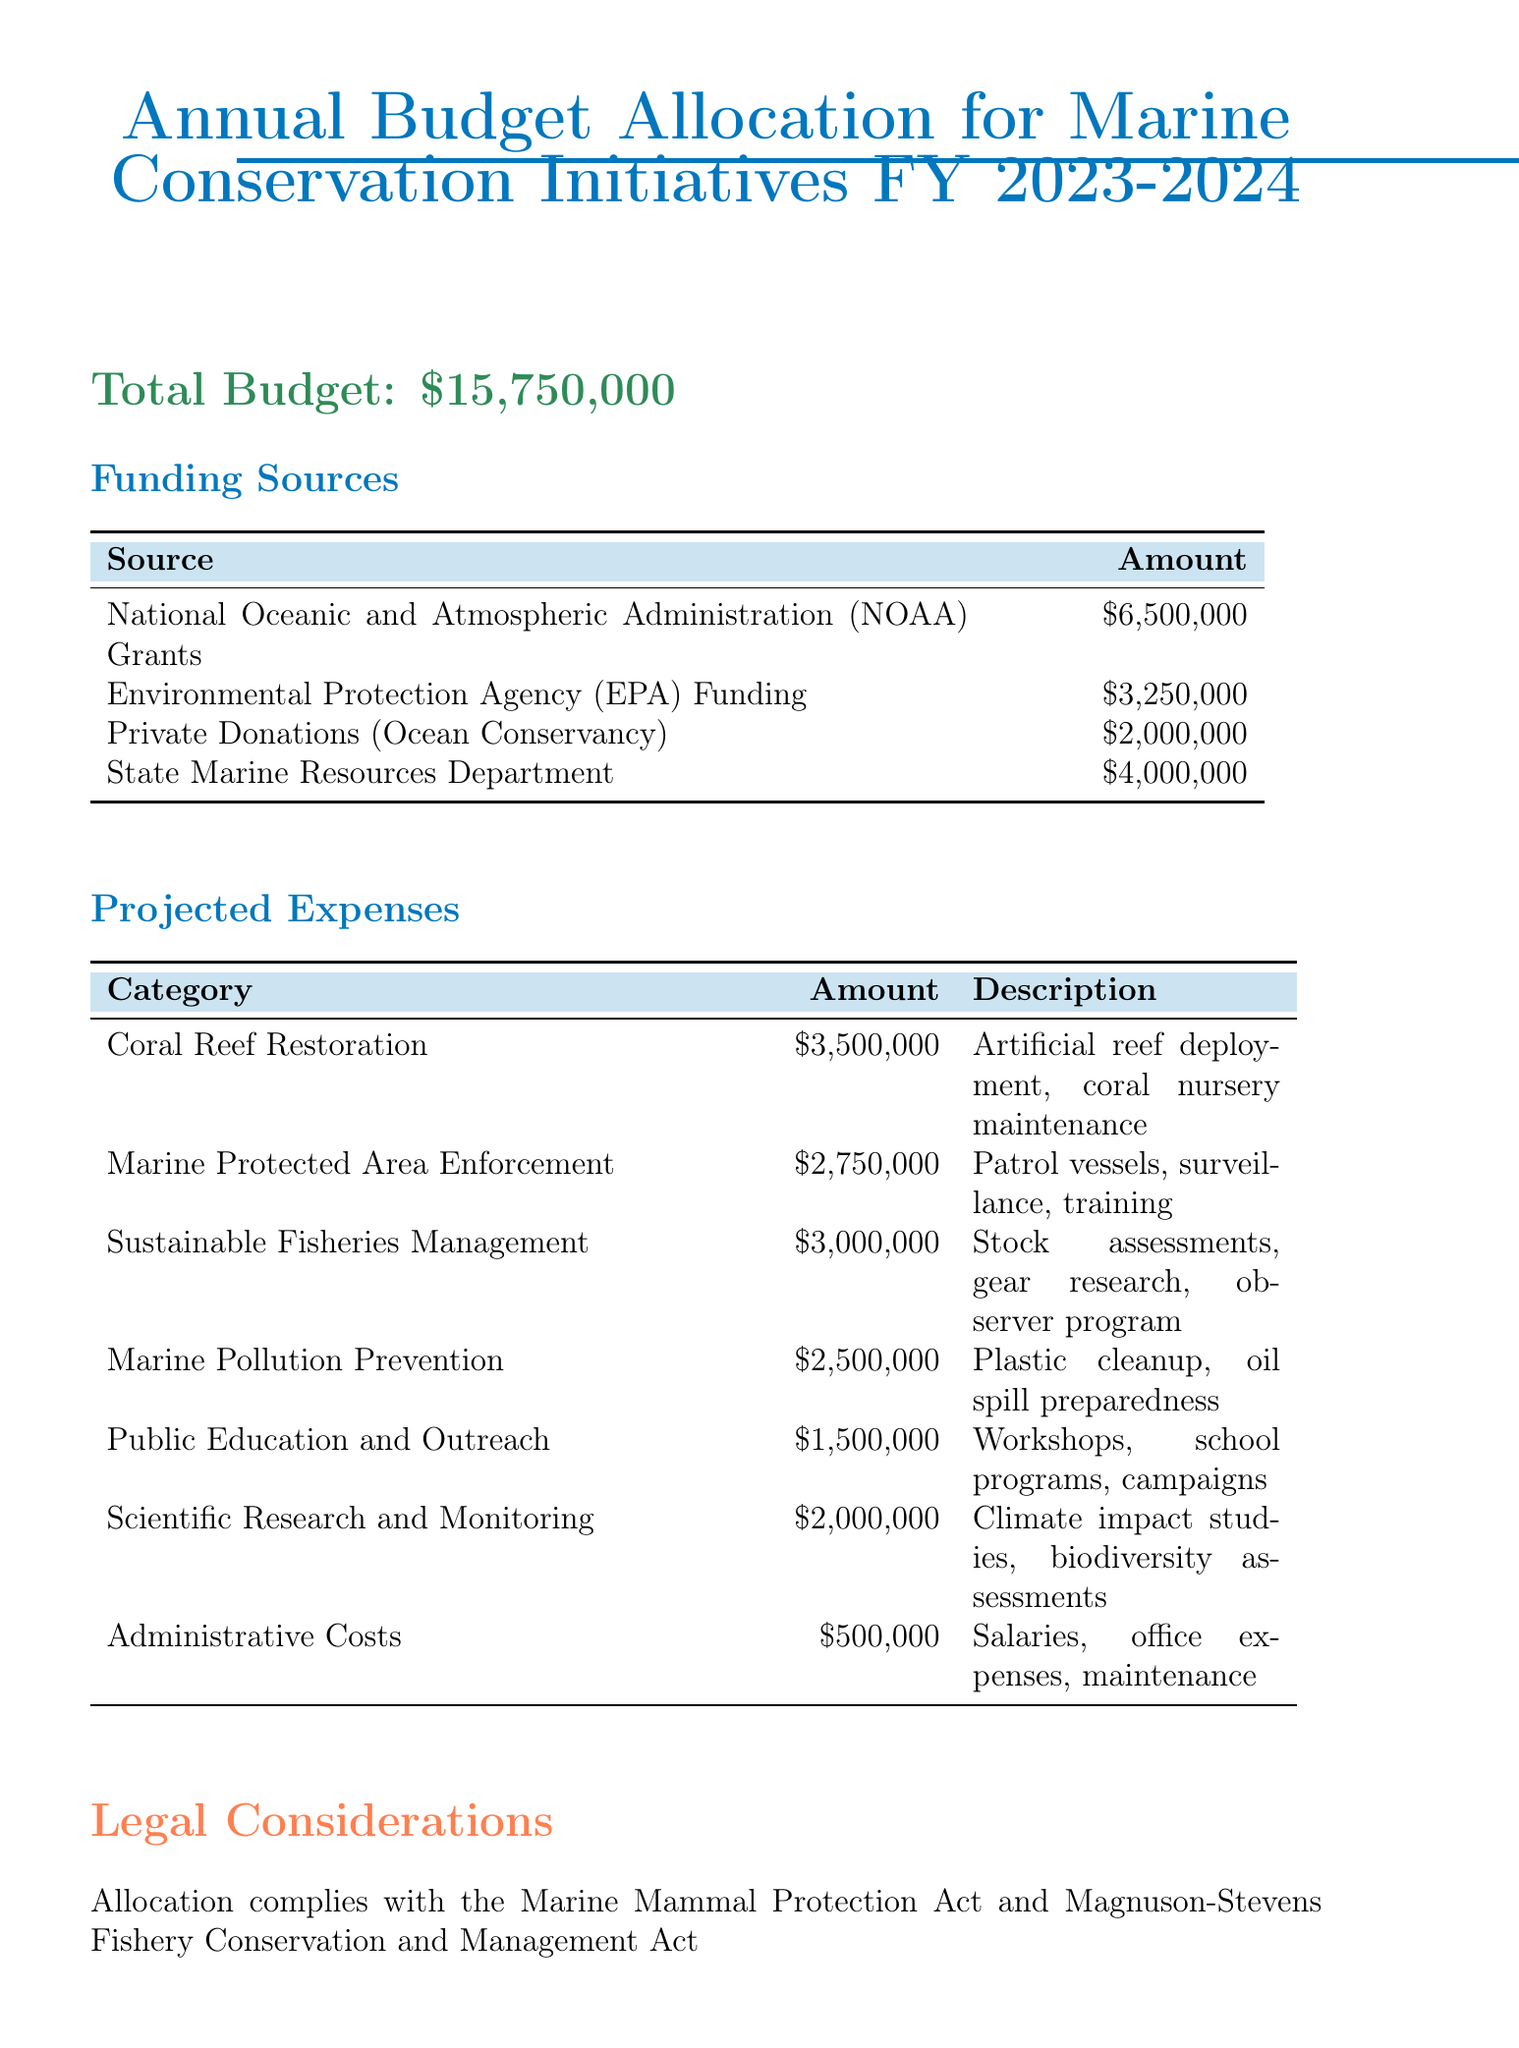What is the total budget? The total budget is stated clearly in the document as the overall financial allocation for the initiatives.
Answer: $15,750,000 How much funding is provided by NOAA Grants? This amount is specified under the funding sources section, detailing contributions from various entities.
Answer: $6,500,000 What is the projected expense for Marine Pollution Prevention? The expense for this category is outlined in the projected expenses section, showing the allocated funds for pollution initiatives.
Answer: $2,500,000 Which initiative has the highest funding allocated? The funding amounts can be compared in various categories, revealing which area receives the most financial support.
Answer: Coral Reef Restoration What are the legal considerations mentioned? This refers to the compliance aspects included in the document, ensuring that the budget allocation adheres to specific laws.
Answer: Marine Mammal Protection Act and Magnuson-Stevens Fishery Conservation and Management Act What is the total amount from Private Donations? This information can be retrieved from the funding sources, highlighting contributions from private entities.
Answer: $2,000,000 Who is the Chief Marine Policy Analyst? The contact information section includes the name and title of the individual responsible for marine policy analysis.
Answer: Dr. Emily Stern What is the expense for Scientific Research and Monitoring? The document specifies the amount allocated for this category under projected expenses, indicating support for research initiatives.
Answer: $2,000,000 